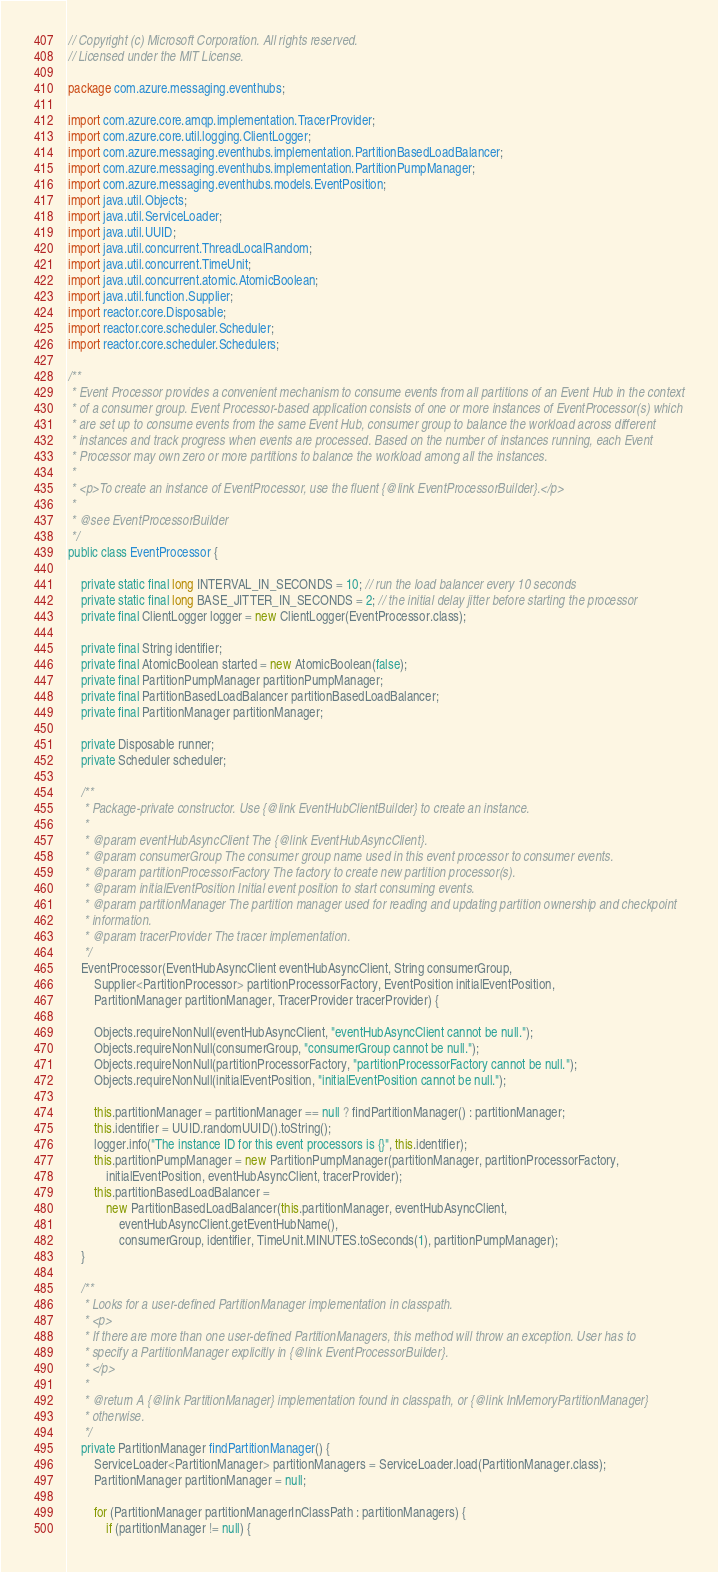<code> <loc_0><loc_0><loc_500><loc_500><_Java_>// Copyright (c) Microsoft Corporation. All rights reserved.
// Licensed under the MIT License.

package com.azure.messaging.eventhubs;

import com.azure.core.amqp.implementation.TracerProvider;
import com.azure.core.util.logging.ClientLogger;
import com.azure.messaging.eventhubs.implementation.PartitionBasedLoadBalancer;
import com.azure.messaging.eventhubs.implementation.PartitionPumpManager;
import com.azure.messaging.eventhubs.models.EventPosition;
import java.util.Objects;
import java.util.ServiceLoader;
import java.util.UUID;
import java.util.concurrent.ThreadLocalRandom;
import java.util.concurrent.TimeUnit;
import java.util.concurrent.atomic.AtomicBoolean;
import java.util.function.Supplier;
import reactor.core.Disposable;
import reactor.core.scheduler.Scheduler;
import reactor.core.scheduler.Schedulers;

/**
 * Event Processor provides a convenient mechanism to consume events from all partitions of an Event Hub in the context
 * of a consumer group. Event Processor-based application consists of one or more instances of EventProcessor(s) which
 * are set up to consume events from the same Event Hub, consumer group to balance the workload across different
 * instances and track progress when events are processed. Based on the number of instances running, each Event
 * Processor may own zero or more partitions to balance the workload among all the instances.
 *
 * <p>To create an instance of EventProcessor, use the fluent {@link EventProcessorBuilder}.</p>
 *
 * @see EventProcessorBuilder
 */
public class EventProcessor {

    private static final long INTERVAL_IN_SECONDS = 10; // run the load balancer every 10 seconds
    private static final long BASE_JITTER_IN_SECONDS = 2; // the initial delay jitter before starting the processor
    private final ClientLogger logger = new ClientLogger(EventProcessor.class);

    private final String identifier;
    private final AtomicBoolean started = new AtomicBoolean(false);
    private final PartitionPumpManager partitionPumpManager;
    private final PartitionBasedLoadBalancer partitionBasedLoadBalancer;
    private final PartitionManager partitionManager;

    private Disposable runner;
    private Scheduler scheduler;

    /**
     * Package-private constructor. Use {@link EventHubClientBuilder} to create an instance.
     *
     * @param eventHubAsyncClient The {@link EventHubAsyncClient}.
     * @param consumerGroup The consumer group name used in this event processor to consumer events.
     * @param partitionProcessorFactory The factory to create new partition processor(s).
     * @param initialEventPosition Initial event position to start consuming events.
     * @param partitionManager The partition manager used for reading and updating partition ownership and checkpoint
     * information.
     * @param tracerProvider The tracer implementation.
     */
    EventProcessor(EventHubAsyncClient eventHubAsyncClient, String consumerGroup,
        Supplier<PartitionProcessor> partitionProcessorFactory, EventPosition initialEventPosition,
        PartitionManager partitionManager, TracerProvider tracerProvider) {

        Objects.requireNonNull(eventHubAsyncClient, "eventHubAsyncClient cannot be null.");
        Objects.requireNonNull(consumerGroup, "consumerGroup cannot be null.");
        Objects.requireNonNull(partitionProcessorFactory, "partitionProcessorFactory cannot be null.");
        Objects.requireNonNull(initialEventPosition, "initialEventPosition cannot be null.");

        this.partitionManager = partitionManager == null ? findPartitionManager() : partitionManager;
        this.identifier = UUID.randomUUID().toString();
        logger.info("The instance ID for this event processors is {}", this.identifier);
        this.partitionPumpManager = new PartitionPumpManager(partitionManager, partitionProcessorFactory,
            initialEventPosition, eventHubAsyncClient, tracerProvider);
        this.partitionBasedLoadBalancer =
            new PartitionBasedLoadBalancer(this.partitionManager, eventHubAsyncClient,
                eventHubAsyncClient.getEventHubName(),
                consumerGroup, identifier, TimeUnit.MINUTES.toSeconds(1), partitionPumpManager);
    }

    /**
     * Looks for a user-defined PartitionManager implementation in classpath.
     * <p>
     * If there are more than one user-defined PartitionManagers, this method will throw an exception. User has to
     * specify a PartitionManager explicitly in {@link EventProcessorBuilder}.
     * </p>
     *
     * @return A {@link PartitionManager} implementation found in classpath, or {@link InMemoryPartitionManager}
     * otherwise.
     */
    private PartitionManager findPartitionManager() {
        ServiceLoader<PartitionManager> partitionManagers = ServiceLoader.load(PartitionManager.class);
        PartitionManager partitionManager = null;

        for (PartitionManager partitionManagerInClassPath : partitionManagers) {
            if (partitionManager != null) {</code> 